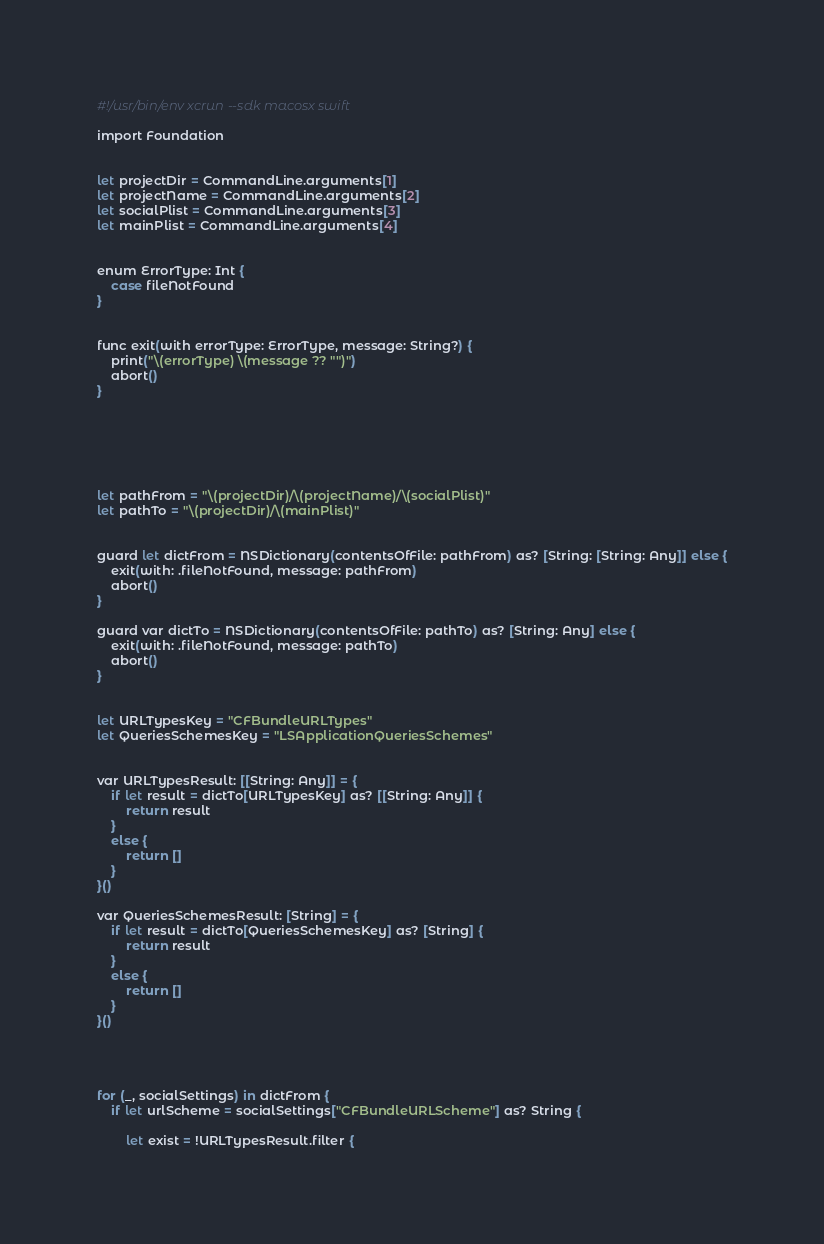Convert code to text. <code><loc_0><loc_0><loc_500><loc_500><_Bash_>#!/usr/bin/env xcrun --sdk macosx swift

import Foundation


let projectDir = CommandLine.arguments[1]
let projectName = CommandLine.arguments[2]
let socialPlist = CommandLine.arguments[3]
let mainPlist = CommandLine.arguments[4]


enum ErrorType: Int {
    case fileNotFound
}


func exit(with errorType: ErrorType, message: String?) {
    print("\(errorType) \(message ?? "")")
    abort()
}






let pathFrom = "\(projectDir)/\(projectName)/\(socialPlist)"
let pathTo = "\(projectDir)/\(mainPlist)"


guard let dictFrom = NSDictionary(contentsOfFile: pathFrom) as? [String: [String: Any]] else {
    exit(with: .fileNotFound, message: pathFrom)
    abort()
}

guard var dictTo = NSDictionary(contentsOfFile: pathTo) as? [String: Any] else {
    exit(with: .fileNotFound, message: pathTo)
    abort()
}


let URLTypesKey = "CFBundleURLTypes"
let QueriesSchemesKey = "LSApplicationQueriesSchemes"


var URLTypesResult: [[String: Any]] = {
    if let result = dictTo[URLTypesKey] as? [[String: Any]] {
        return result
    }
    else {
        return []
    }
}()

var QueriesSchemesResult: [String] = {
    if let result = dictTo[QueriesSchemesKey] as? [String] {
        return result
    }
    else {
        return []
    }
}()




for (_, socialSettings) in dictFrom {
    if let urlScheme = socialSettings["CFBundleURLScheme"] as? String {
        
        let exist = !URLTypesResult.filter {</code> 